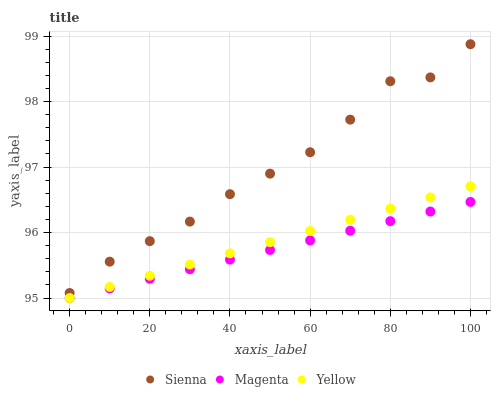Does Magenta have the minimum area under the curve?
Answer yes or no. Yes. Does Sienna have the maximum area under the curve?
Answer yes or no. Yes. Does Yellow have the minimum area under the curve?
Answer yes or no. No. Does Yellow have the maximum area under the curve?
Answer yes or no. No. Is Yellow the smoothest?
Answer yes or no. Yes. Is Sienna the roughest?
Answer yes or no. Yes. Is Magenta the smoothest?
Answer yes or no. No. Is Magenta the roughest?
Answer yes or no. No. Does Magenta have the lowest value?
Answer yes or no. Yes. Does Sienna have the highest value?
Answer yes or no. Yes. Does Yellow have the highest value?
Answer yes or no. No. Is Magenta less than Sienna?
Answer yes or no. Yes. Is Sienna greater than Magenta?
Answer yes or no. Yes. Does Yellow intersect Magenta?
Answer yes or no. Yes. Is Yellow less than Magenta?
Answer yes or no. No. Is Yellow greater than Magenta?
Answer yes or no. No. Does Magenta intersect Sienna?
Answer yes or no. No. 